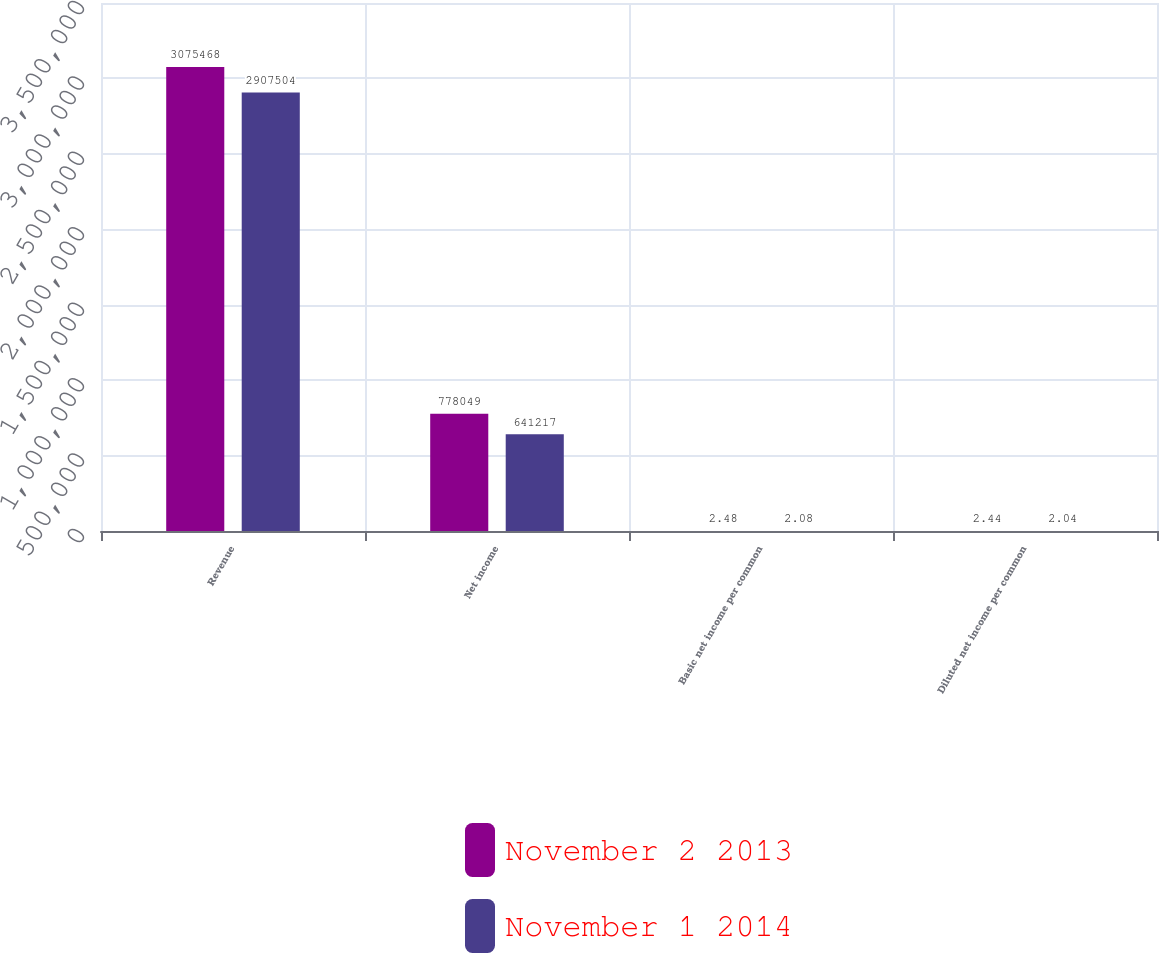Convert chart to OTSL. <chart><loc_0><loc_0><loc_500><loc_500><stacked_bar_chart><ecel><fcel>Revenue<fcel>Net income<fcel>Basic net income per common<fcel>Diluted net income per common<nl><fcel>November 2 2013<fcel>3.07547e+06<fcel>778049<fcel>2.48<fcel>2.44<nl><fcel>November 1 2014<fcel>2.9075e+06<fcel>641217<fcel>2.08<fcel>2.04<nl></chart> 